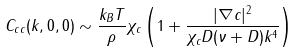Convert formula to latex. <formula><loc_0><loc_0><loc_500><loc_500>C _ { c c } ( k , 0 , 0 ) \sim \frac { k _ { B } T } { \rho } \chi _ { c } \left ( 1 + \frac { | \nabla c | ^ { 2 } } { \chi _ { c } D ( \nu + D ) k ^ { 4 } } \right )</formula> 